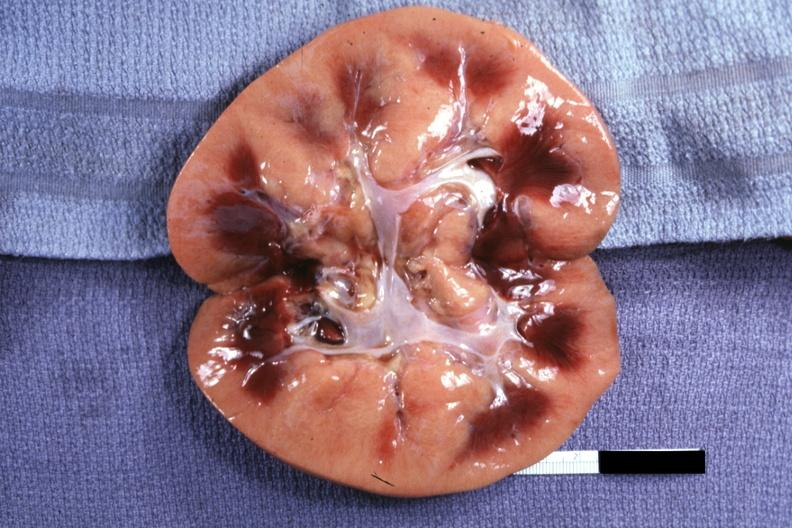what does this image show?
Answer the question using a single word or phrase. Obviously greatly swollen and pale kidney 